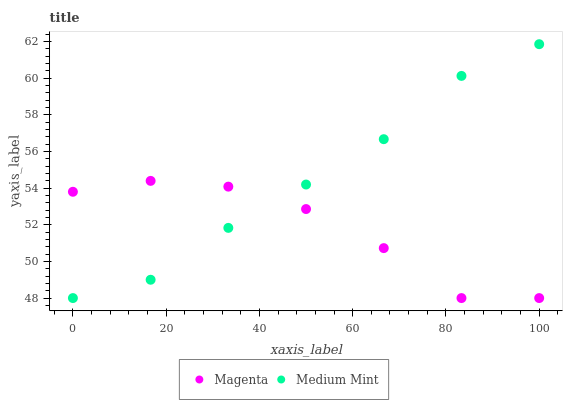Does Magenta have the minimum area under the curve?
Answer yes or no. Yes. Does Medium Mint have the maximum area under the curve?
Answer yes or no. Yes. Does Magenta have the maximum area under the curve?
Answer yes or no. No. Is Medium Mint the smoothest?
Answer yes or no. Yes. Is Magenta the roughest?
Answer yes or no. Yes. Is Magenta the smoothest?
Answer yes or no. No. Does Medium Mint have the lowest value?
Answer yes or no. Yes. Does Medium Mint have the highest value?
Answer yes or no. Yes. Does Magenta have the highest value?
Answer yes or no. No. Does Magenta intersect Medium Mint?
Answer yes or no. Yes. Is Magenta less than Medium Mint?
Answer yes or no. No. Is Magenta greater than Medium Mint?
Answer yes or no. No. 